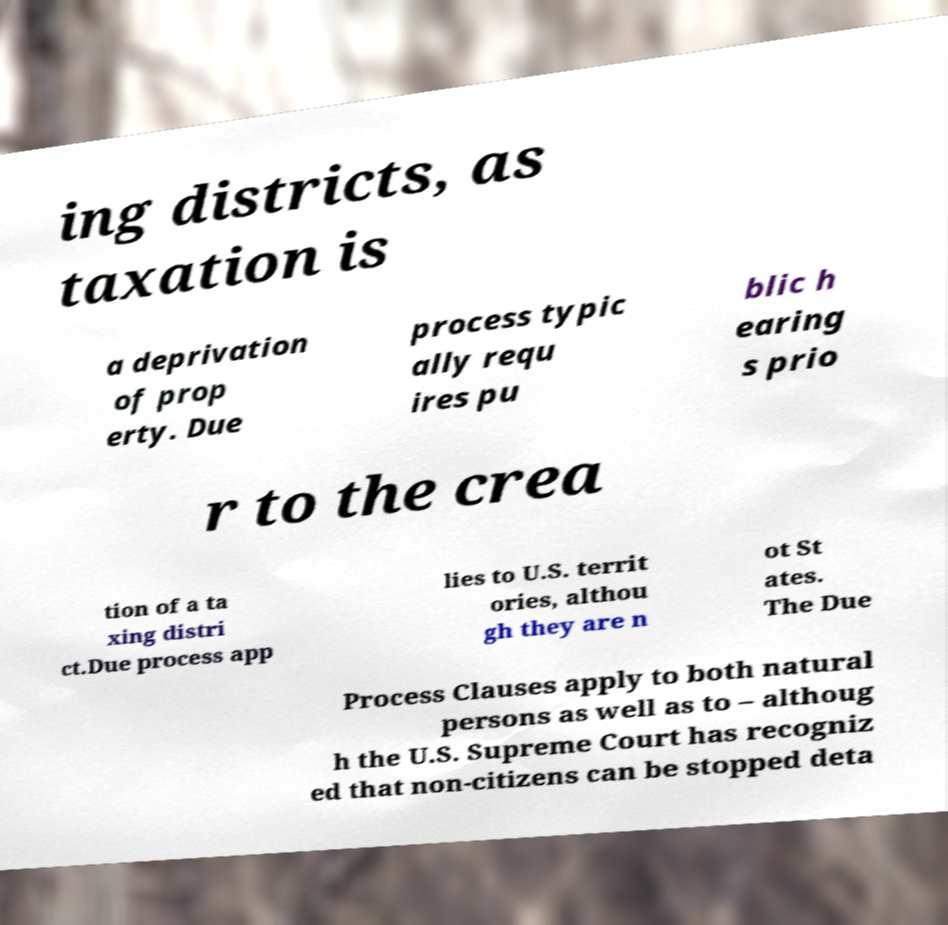Please identify and transcribe the text found in this image. ing districts, as taxation is a deprivation of prop erty. Due process typic ally requ ires pu blic h earing s prio r to the crea tion of a ta xing distri ct.Due process app lies to U.S. territ ories, althou gh they are n ot St ates. The Due Process Clauses apply to both natural persons as well as to – althoug h the U.S. Supreme Court has recogniz ed that non-citizens can be stopped deta 